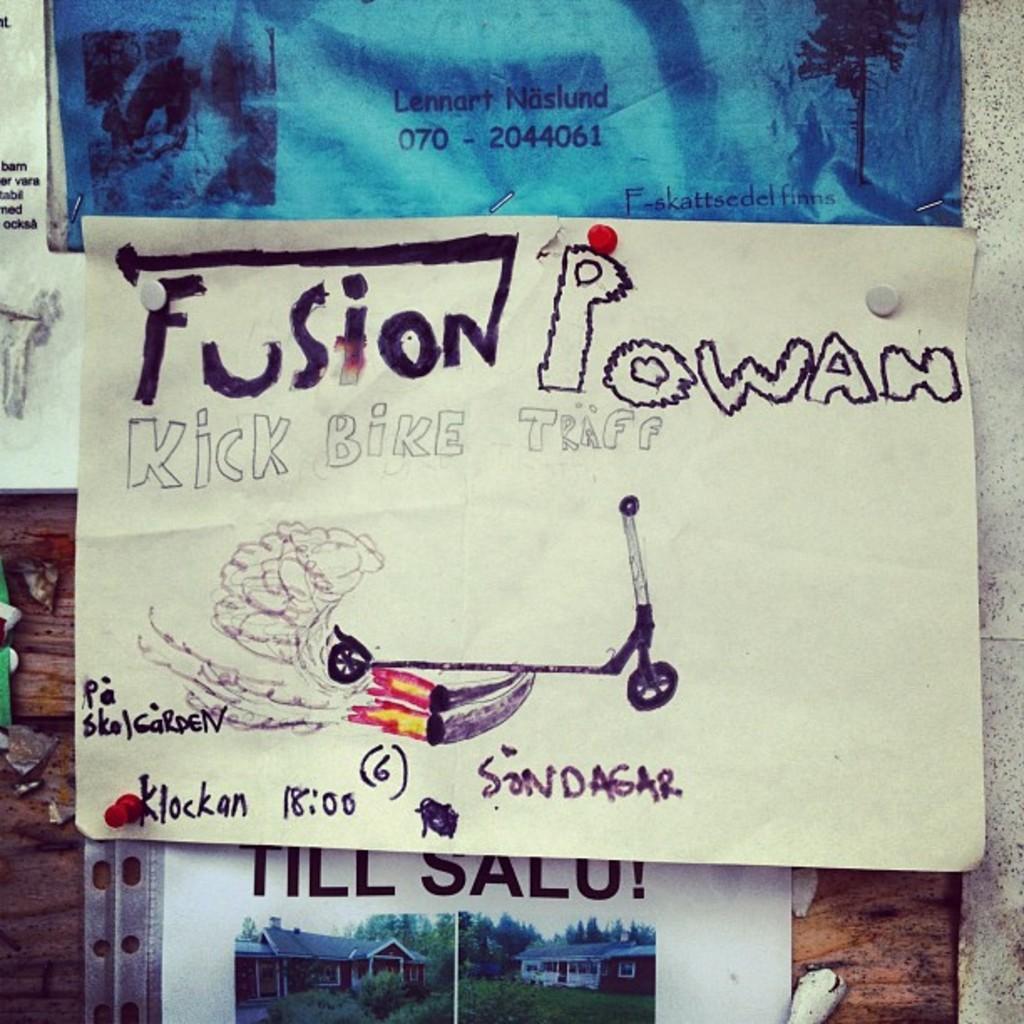Describe this image in one or two sentences. In the center of this picture we can see the posters hanging on the wall and we can see the text and the pictures of some objects on the posters. 